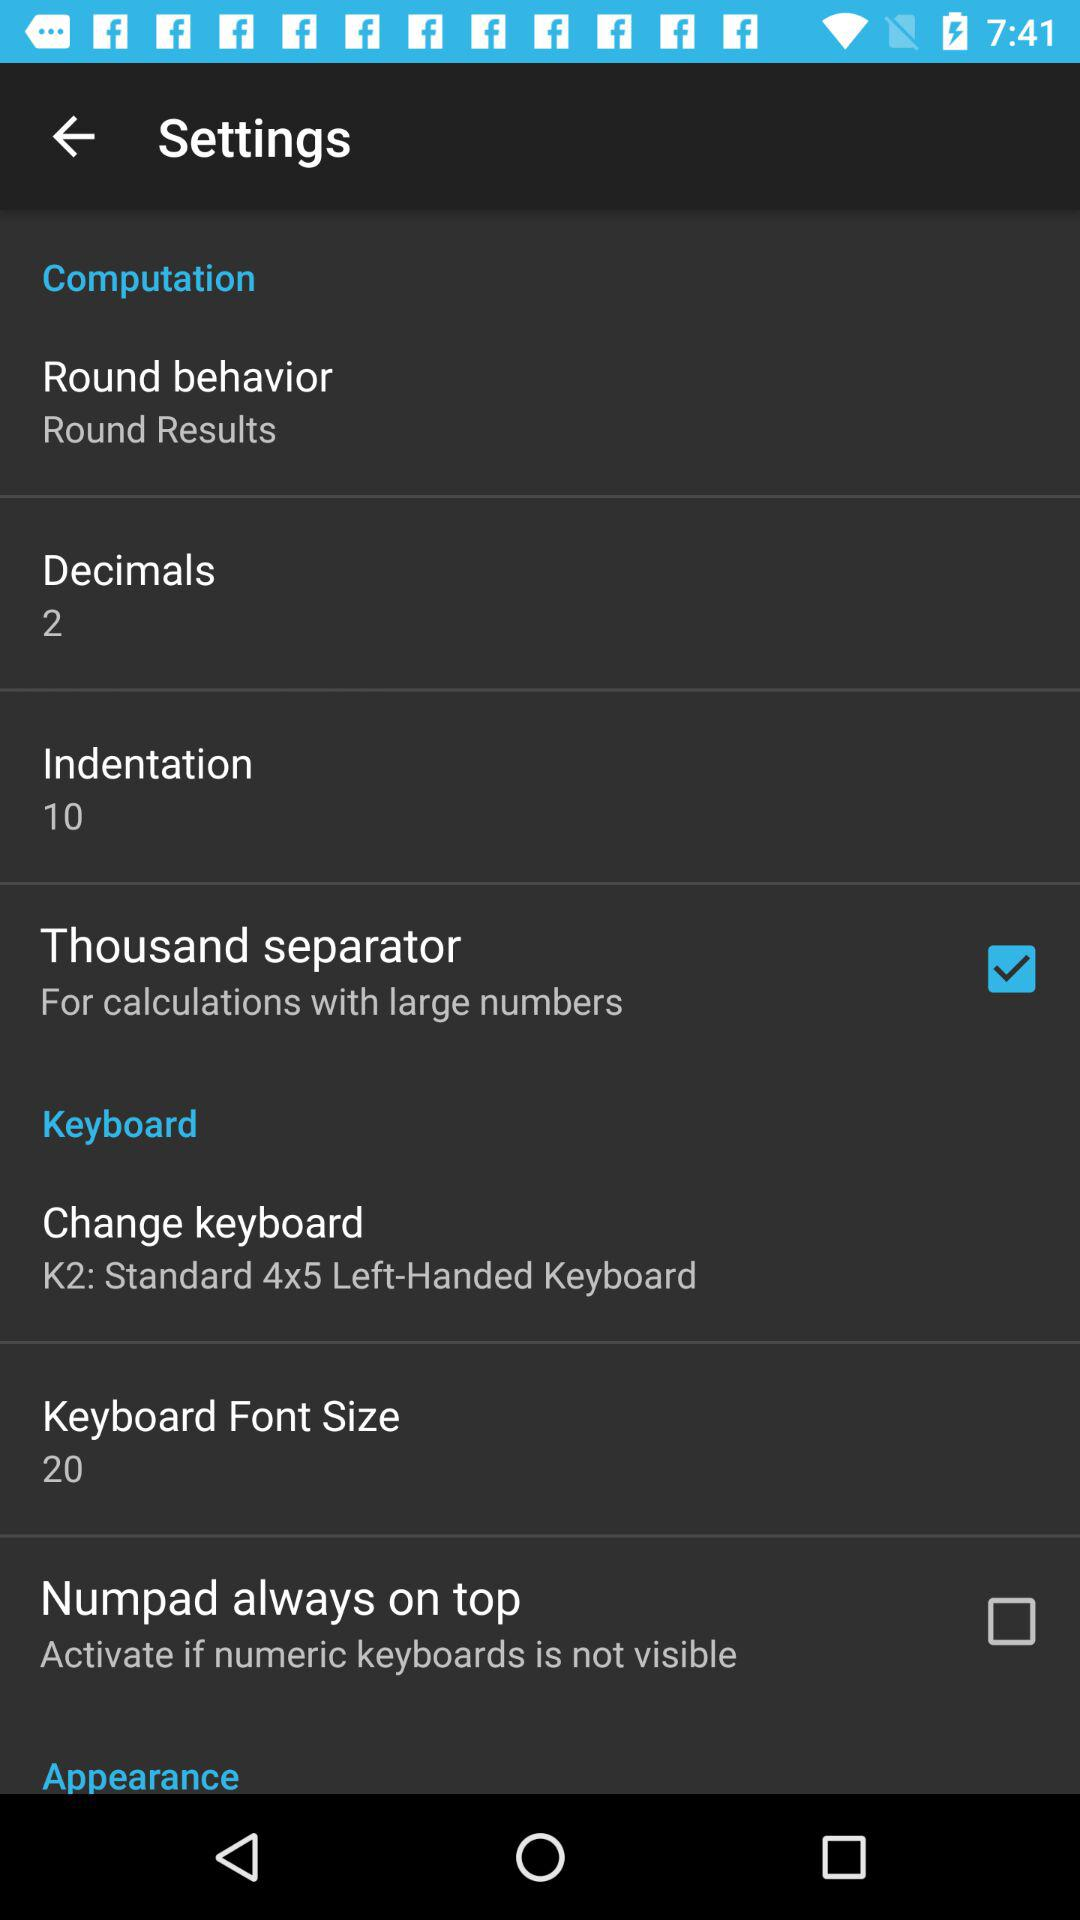What is the status of "Thousand separator"? The status is "on". 